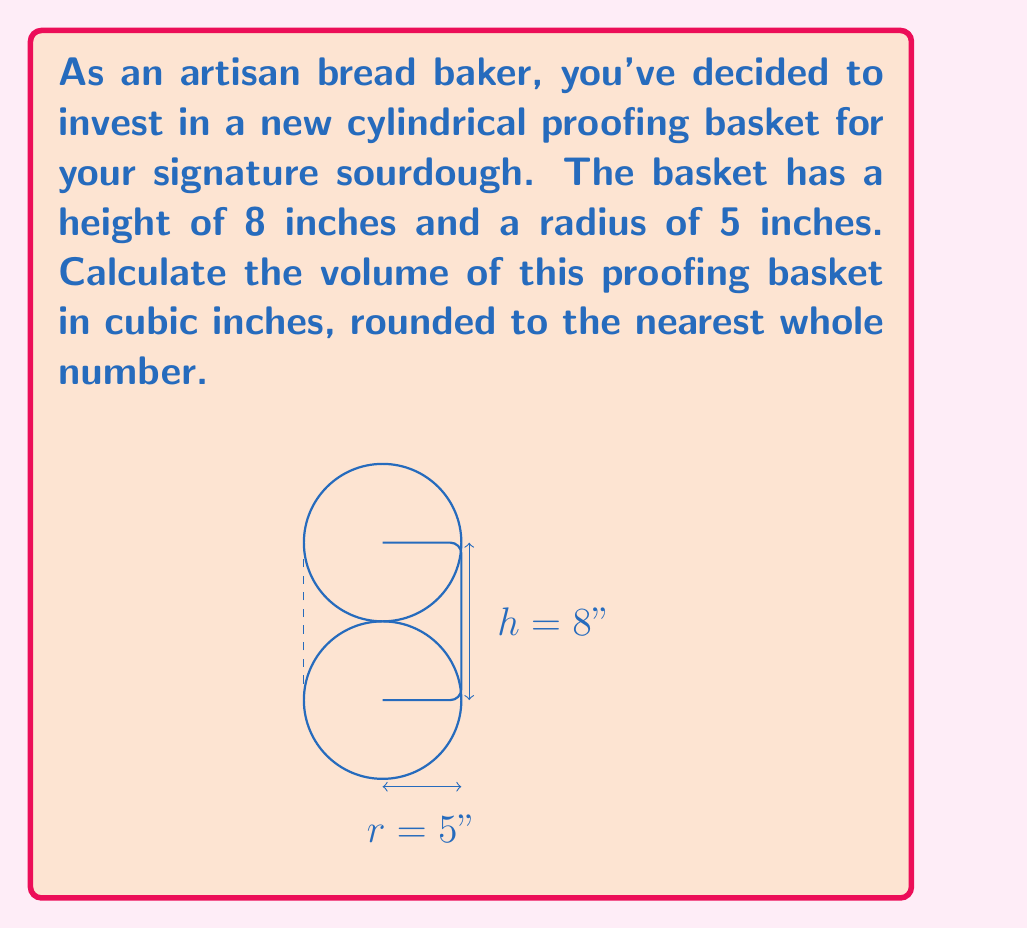What is the answer to this math problem? To calculate the volume of a cylindrical proofing basket, we use the formula for the volume of a cylinder:

$$V = \pi r^2 h$$

Where:
$V$ = volume
$r$ = radius of the base
$h$ = height of the cylinder

Given:
$r = 5$ inches
$h = 8$ inches

Let's substitute these values into the formula:

$$\begin{align}
V &= \pi r^2 h \\
&= \pi \cdot (5\text{ in})^2 \cdot 8\text{ in} \\
&= \pi \cdot 25\text{ in}^2 \cdot 8\text{ in} \\
&= 200\pi\text{ in}^3
\end{align}$$

Now, let's calculate this value:

$$200\pi \approx 628.32\text{ in}^3$$

Rounding to the nearest whole number:

$$628.32\text{ in}^3 \approx 628\text{ in}^3$$

Therefore, the volume of the proofing basket is approximately 628 cubic inches.
Answer: $628\text{ in}^3$ 